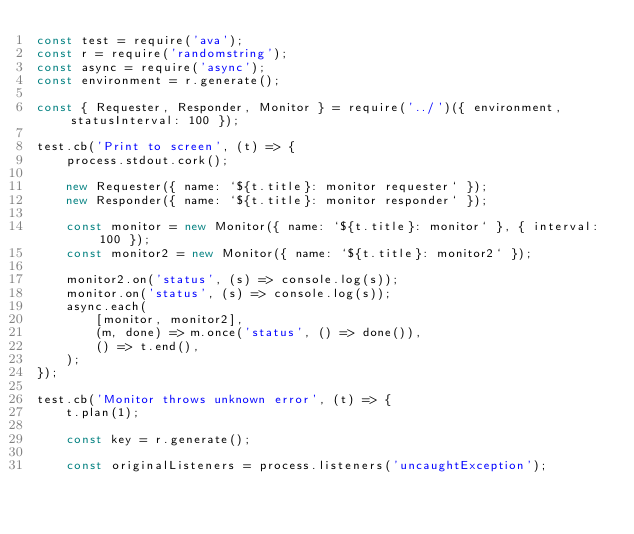<code> <loc_0><loc_0><loc_500><loc_500><_JavaScript_>const test = require('ava');
const r = require('randomstring');
const async = require('async');
const environment = r.generate();

const { Requester, Responder, Monitor } = require('../')({ environment, statusInterval: 100 });

test.cb('Print to screen', (t) => {
    process.stdout.cork();

    new Requester({ name: `${t.title}: monitor requester` });
    new Responder({ name: `${t.title}: monitor responder` });

    const monitor = new Monitor({ name: `${t.title}: monitor` }, { interval: 100 });
    const monitor2 = new Monitor({ name: `${t.title}: monitor2` });

    monitor2.on('status', (s) => console.log(s));
    monitor.on('status', (s) => console.log(s));
    async.each(
        [monitor, monitor2],
        (m, done) => m.once('status', () => done()),
        () => t.end(),
    );
});

test.cb('Monitor throws unknown error', (t) => {
    t.plan(1);

    const key = r.generate();

    const originalListeners = process.listeners('uncaughtException');
</code> 